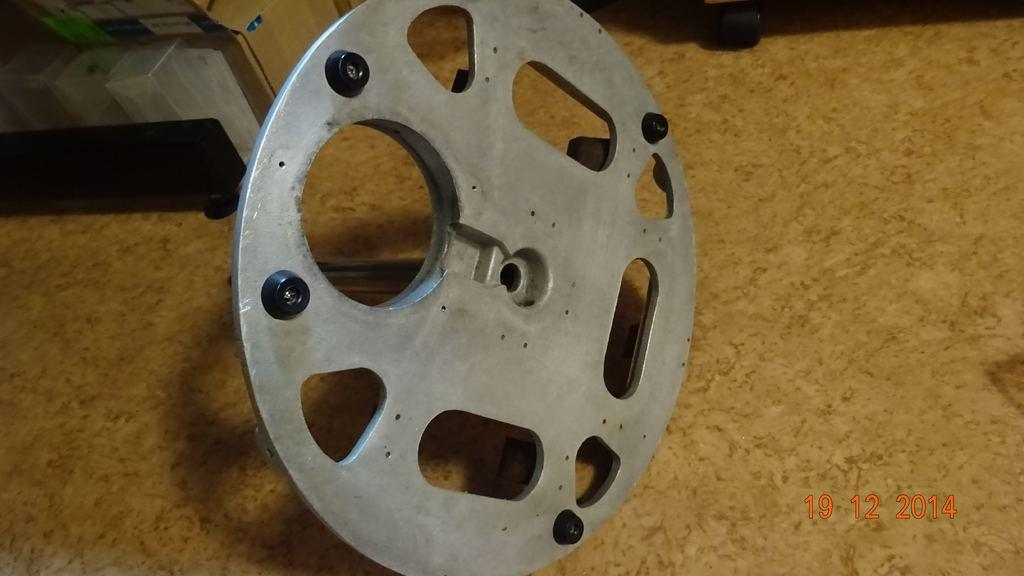What type of wheel is in the image? There is an aluminium wheel in the image. How is the wheel connected to the floor? The wheel is attached to a small rod on the floor. What can be seen on the right side of the image? There is a watermark on the right side of the image. What else can be seen in the background of the image? There are other objects visible in the background of the image. What type of lunch is being served in the image? There is no lunch visible in the image; it features an aluminium wheel attached to a small rod on the floor. How many dogs are present in the image? There are no dogs present in the image. 